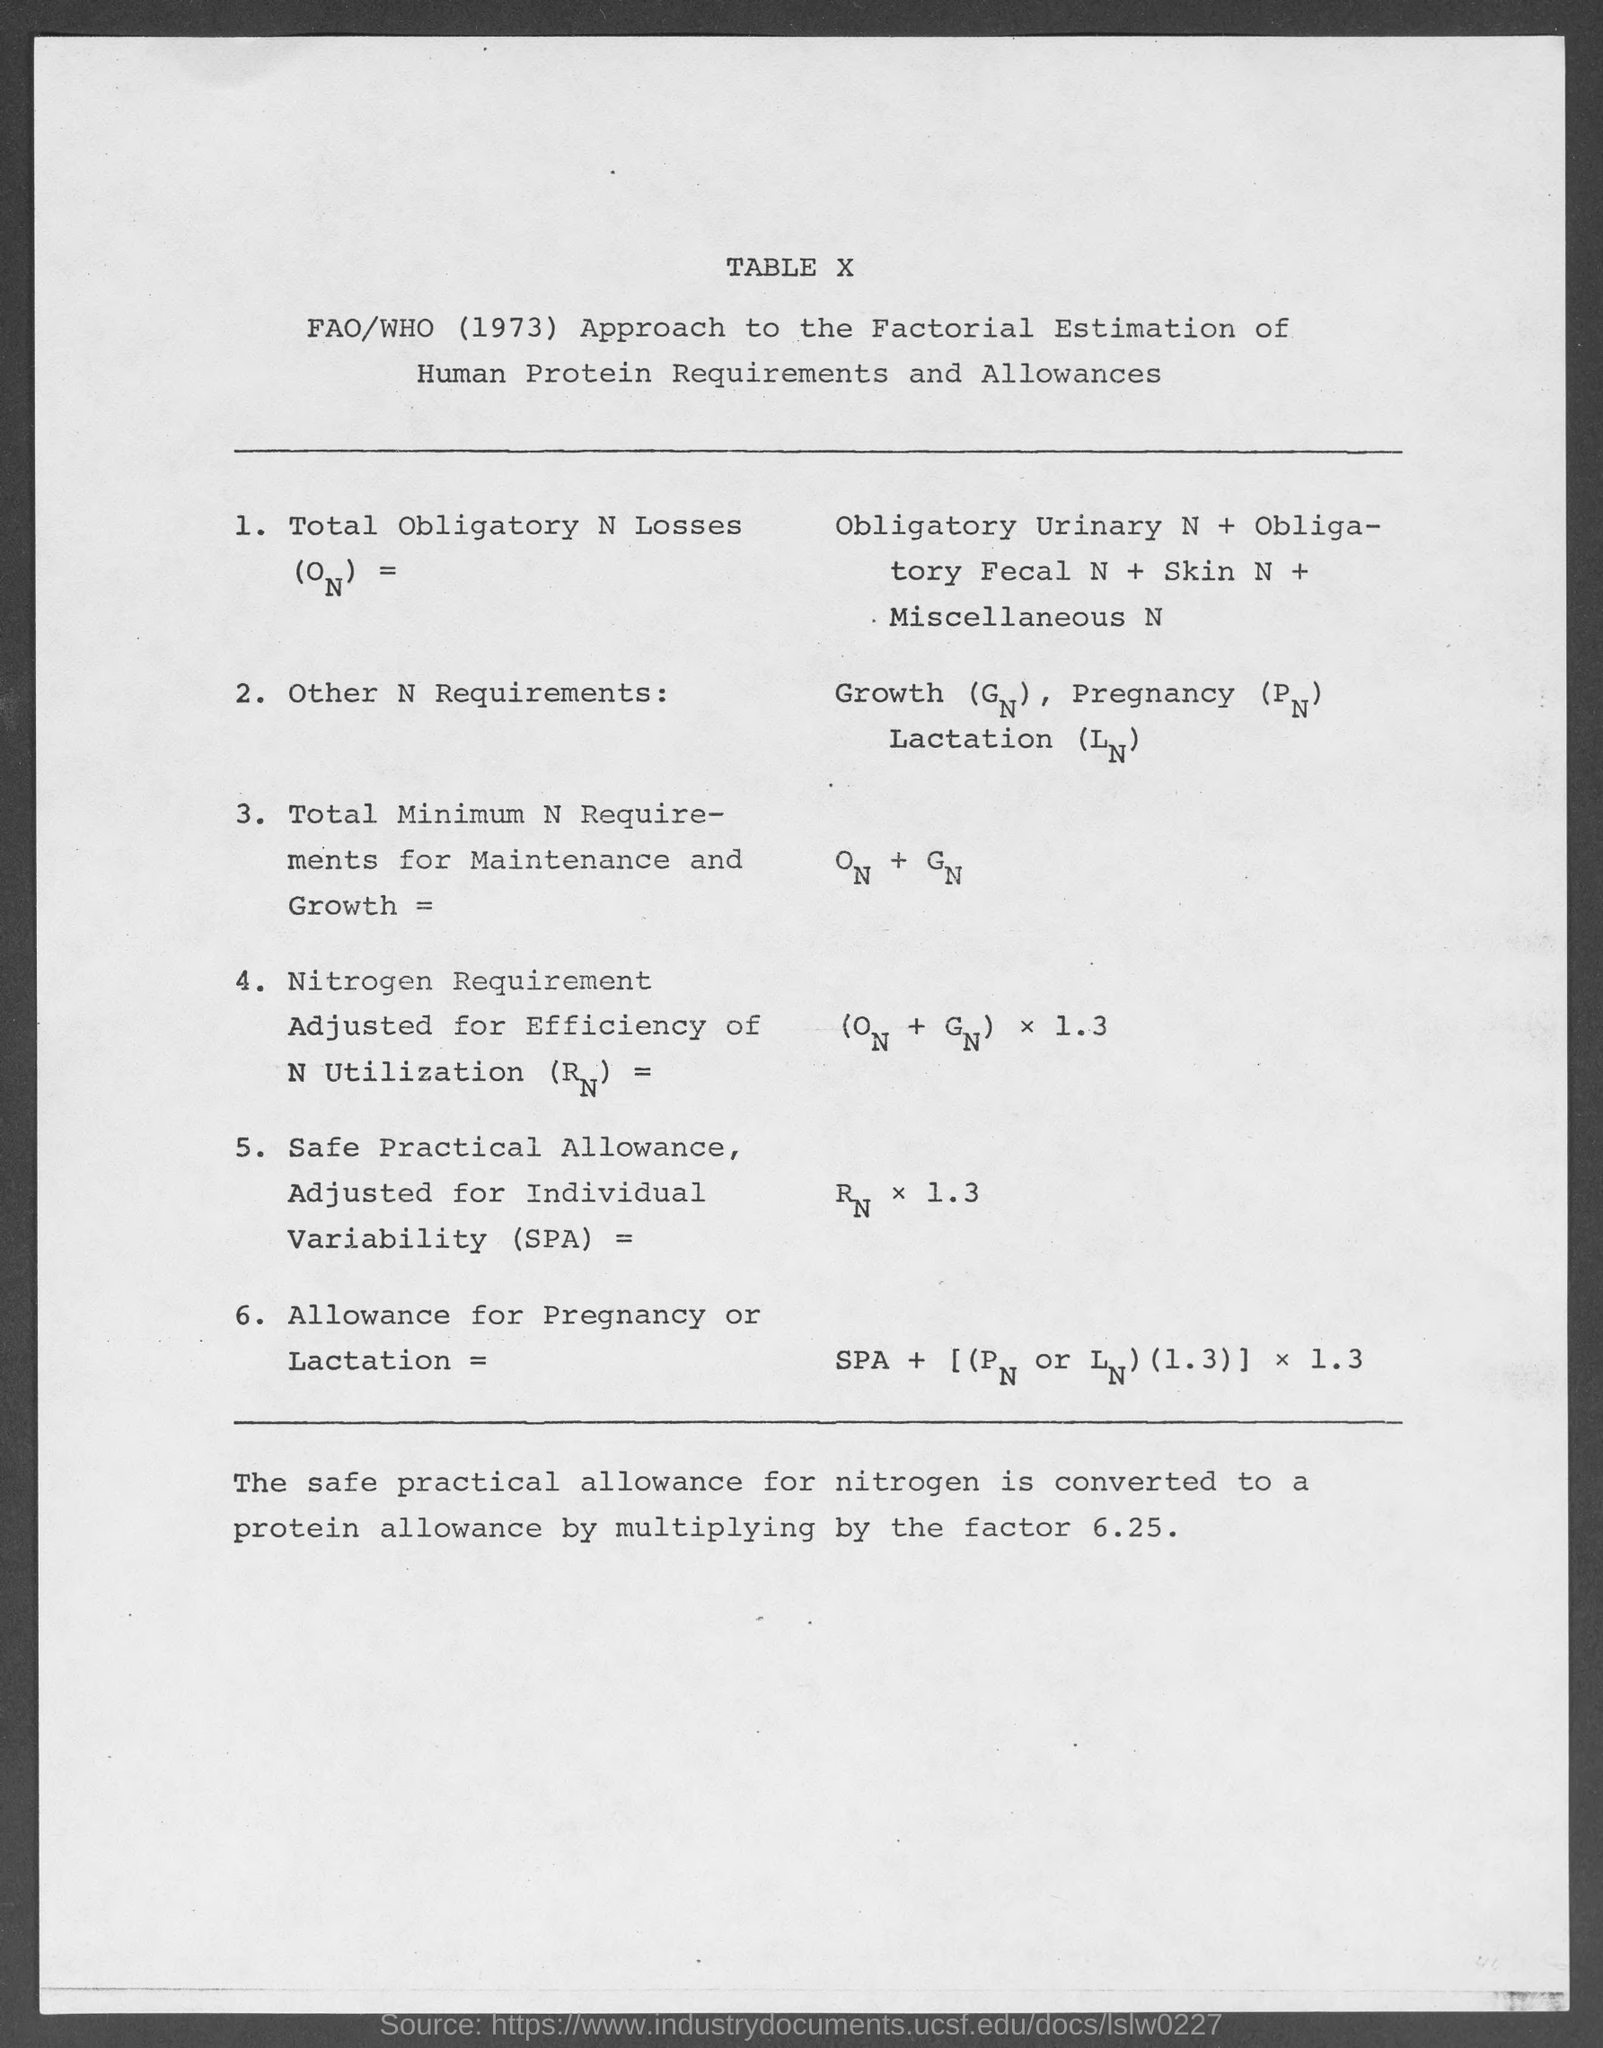What is the table no.?
Make the answer very short. Table x. 